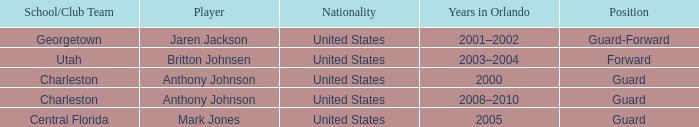What was the Position of the Player, Britton Johnsen? Forward. 